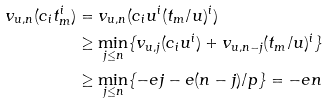<formula> <loc_0><loc_0><loc_500><loc_500>v _ { u , n } ( c _ { i } t _ { m } ^ { i } ) & = v _ { u , n } ( c _ { i } u ^ { i } ( t _ { m } / u ) ^ { i } ) \\ & \geq \min _ { j \leq n } \{ v _ { u , j } ( c _ { i } u ^ { i } ) + v _ { u , n - j } ( t _ { m } / u ) ^ { i } \} \\ & \geq \min _ { j \leq n } \{ - e j - e ( n - j ) / p \} = - e n</formula> 